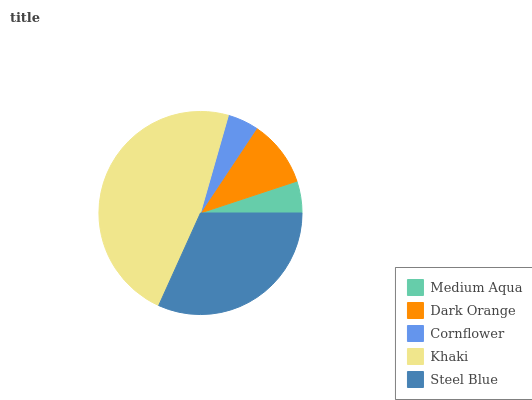Is Cornflower the minimum?
Answer yes or no. Yes. Is Khaki the maximum?
Answer yes or no. Yes. Is Dark Orange the minimum?
Answer yes or no. No. Is Dark Orange the maximum?
Answer yes or no. No. Is Dark Orange greater than Medium Aqua?
Answer yes or no. Yes. Is Medium Aqua less than Dark Orange?
Answer yes or no. Yes. Is Medium Aqua greater than Dark Orange?
Answer yes or no. No. Is Dark Orange less than Medium Aqua?
Answer yes or no. No. Is Dark Orange the high median?
Answer yes or no. Yes. Is Dark Orange the low median?
Answer yes or no. Yes. Is Cornflower the high median?
Answer yes or no. No. Is Khaki the low median?
Answer yes or no. No. 